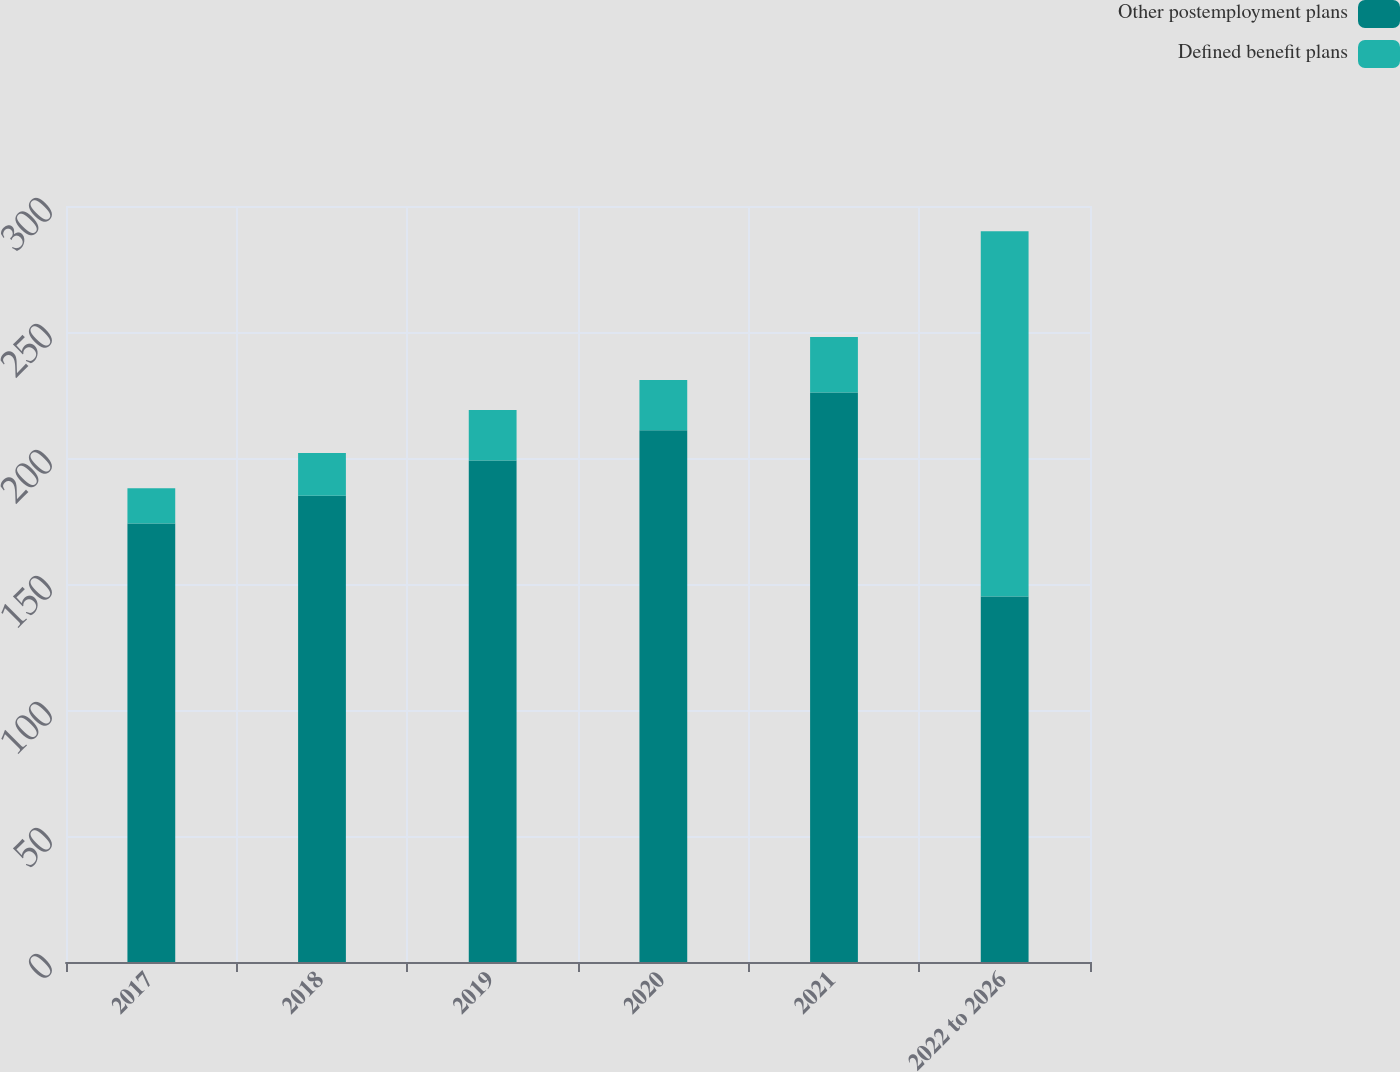Convert chart to OTSL. <chart><loc_0><loc_0><loc_500><loc_500><stacked_bar_chart><ecel><fcel>2017<fcel>2018<fcel>2019<fcel>2020<fcel>2021<fcel>2022 to 2026<nl><fcel>Other postemployment plans<fcel>174<fcel>185<fcel>199<fcel>211<fcel>226<fcel>145<nl><fcel>Defined benefit plans<fcel>14<fcel>17<fcel>20<fcel>20<fcel>22<fcel>145<nl></chart> 